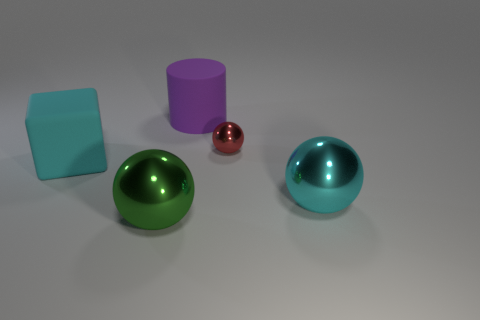Subtract all big cyan shiny balls. How many balls are left? 2 Add 5 big brown shiny cylinders. How many objects exist? 10 Subtract all cyan spheres. How many spheres are left? 2 Subtract all spheres. How many objects are left? 2 Subtract 1 cylinders. How many cylinders are left? 0 Subtract all green spheres. Subtract all yellow cylinders. How many spheres are left? 2 Subtract all purple cylinders. How many red spheres are left? 1 Subtract all large blue metallic cylinders. Subtract all big rubber cylinders. How many objects are left? 4 Add 3 big green spheres. How many big green spheres are left? 4 Add 2 green metal balls. How many green metal balls exist? 3 